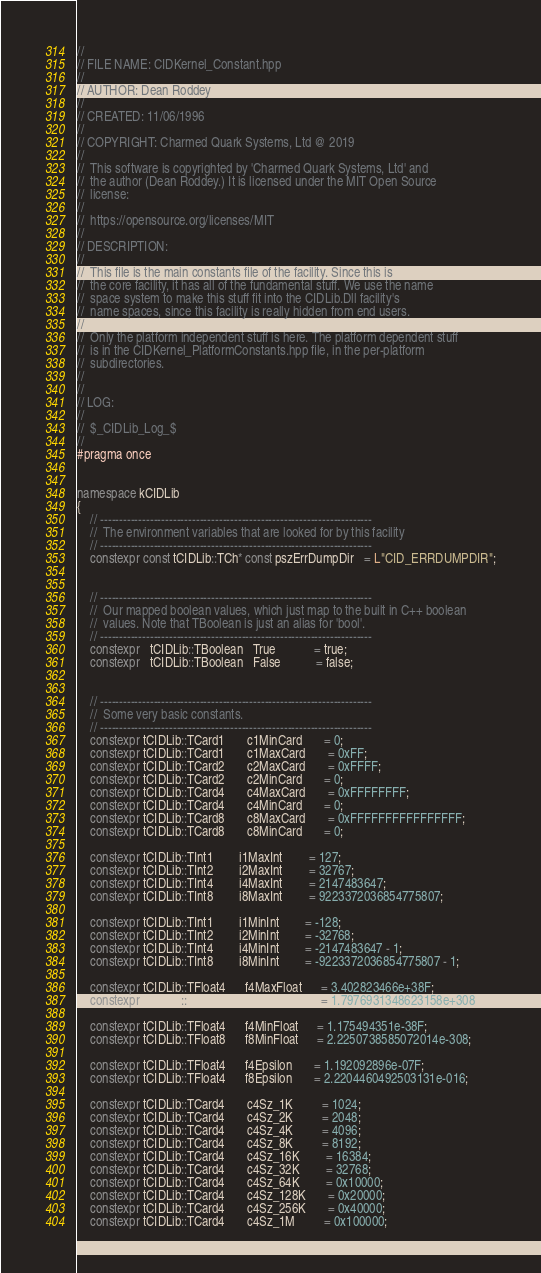<code> <loc_0><loc_0><loc_500><loc_500><_C++_>//
// FILE NAME: CIDKernel_Constant.hpp
//
// AUTHOR: Dean Roddey
//
// CREATED: 11/06/1996
//
// COPYRIGHT: Charmed Quark Systems, Ltd @ 2019
//
//  This software is copyrighted by 'Charmed Quark Systems, Ltd' and
//  the author (Dean Roddey.) It is licensed under the MIT Open Source
//  license:
//
//  https://opensource.org/licenses/MIT
//
// DESCRIPTION:
//
//  This file is the main constants file of the facility. Since this is
//  the core facility, it has all of the fundamental stuff. We use the name
//  space system to make this stuff fit into the CIDLib.Dll facility's
//  name spaces, since this facility is really hidden from end users.
//
//  Only the platform independent stuff is here. The platform dependent stuff
//  is in the CIDKernel_PlatformConstants.hpp file, in the per-platform
//  subdirectories.
//
//
// LOG:
//
//  $_CIDLib_Log_$
//
#pragma once


namespace kCIDLib
{
    // -----------------------------------------------------------------------
    //  The environment variables that are looked for by this facility
    // -----------------------------------------------------------------------
    constexpr const tCIDLib::TCh* const pszErrDumpDir   = L"CID_ERRDUMPDIR";


    // -----------------------------------------------------------------------
    //  Our mapped boolean values, which just map to the built in C++ boolean
    //  values. Note that TBoolean is just an alias for 'bool'.
    // -----------------------------------------------------------------------
    constexpr   tCIDLib::TBoolean   True            = true;
    constexpr   tCIDLib::TBoolean   False           = false;


    // -----------------------------------------------------------------------
    //  Some very basic constants.
    // -----------------------------------------------------------------------
    constexpr tCIDLib::TCard1       c1MinCard       = 0;
    constexpr tCIDLib::TCard1       c1MaxCard       = 0xFF;
    constexpr tCIDLib::TCard2       c2MaxCard       = 0xFFFF;
    constexpr tCIDLib::TCard2       c2MinCard       = 0;
    constexpr tCIDLib::TCard4       c4MaxCard       = 0xFFFFFFFF;
    constexpr tCIDLib::TCard4       c4MinCard       = 0;
    constexpr tCIDLib::TCard8       c8MaxCard       = 0xFFFFFFFFFFFFFFFF;
    constexpr tCIDLib::TCard8       c8MinCard       = 0;

    constexpr tCIDLib::TInt1        i1MaxInt        = 127;
    constexpr tCIDLib::TInt2        i2MaxInt        = 32767;
    constexpr tCIDLib::TInt4        i4MaxInt        = 2147483647;
    constexpr tCIDLib::TInt8        i8MaxInt        = 9223372036854775807;

    constexpr tCIDLib::TInt1        i1MinInt        = -128;
    constexpr tCIDLib::TInt2        i2MinInt        = -32768;
    constexpr tCIDLib::TInt4        i4MinInt        = -2147483647 - 1;
    constexpr tCIDLib::TInt8        i8MinInt        = -9223372036854775807 - 1;

    constexpr tCIDLib::TFloat4      f4MaxFloat      = 3.402823466e+38F;
    constexpr tCIDLib::TFloat8      f8MaxFloat      = 1.7976931348623158e+308;

    constexpr tCIDLib::TFloat4      f4MinFloat      = 1.175494351e-38F;
    constexpr tCIDLib::TFloat8      f8MinFloat      = 2.2250738585072014e-308;

    constexpr tCIDLib::TFloat4      f4Epsilon       = 1.192092896e-07F;
    constexpr tCIDLib::TFloat4      f8Epsilon       = 2.2204460492503131e-016;

    constexpr tCIDLib::TCard4       c4Sz_1K         = 1024;
    constexpr tCIDLib::TCard4       c4Sz_2K         = 2048;
    constexpr tCIDLib::TCard4       c4Sz_4K         = 4096;
    constexpr tCIDLib::TCard4       c4Sz_8K         = 8192;
    constexpr tCIDLib::TCard4       c4Sz_16K        = 16384;
    constexpr tCIDLib::TCard4       c4Sz_32K        = 32768;
    constexpr tCIDLib::TCard4       c4Sz_64K        = 0x10000;
    constexpr tCIDLib::TCard4       c4Sz_128K       = 0x20000;
    constexpr tCIDLib::TCard4       c4Sz_256K       = 0x40000;
    constexpr tCIDLib::TCard4       c4Sz_1M         = 0x100000;</code> 